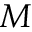Convert formula to latex. <formula><loc_0><loc_0><loc_500><loc_500>M</formula> 